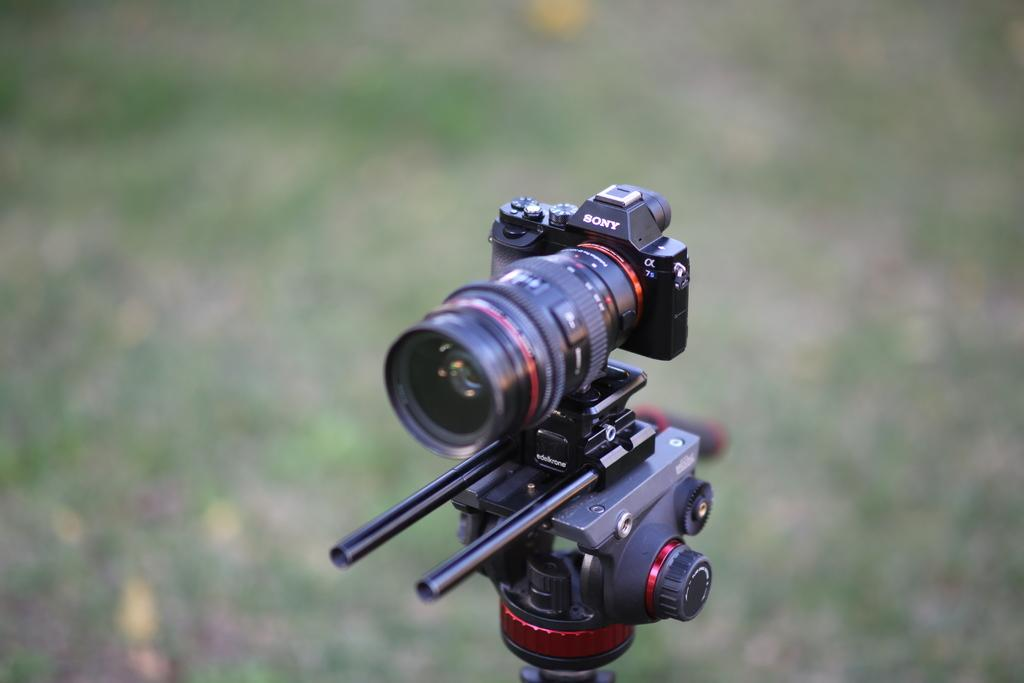What object is the main subject of the image? There is a camera in the image. What can be observed about the background of the image? The background of the image is blurry. Where is the mom in the image? There is no mom present in the image; it only features a camera. What type of weather condition is depicted in the image? The image does not depict any weather conditions, as it only shows a camera and a blurry background. 